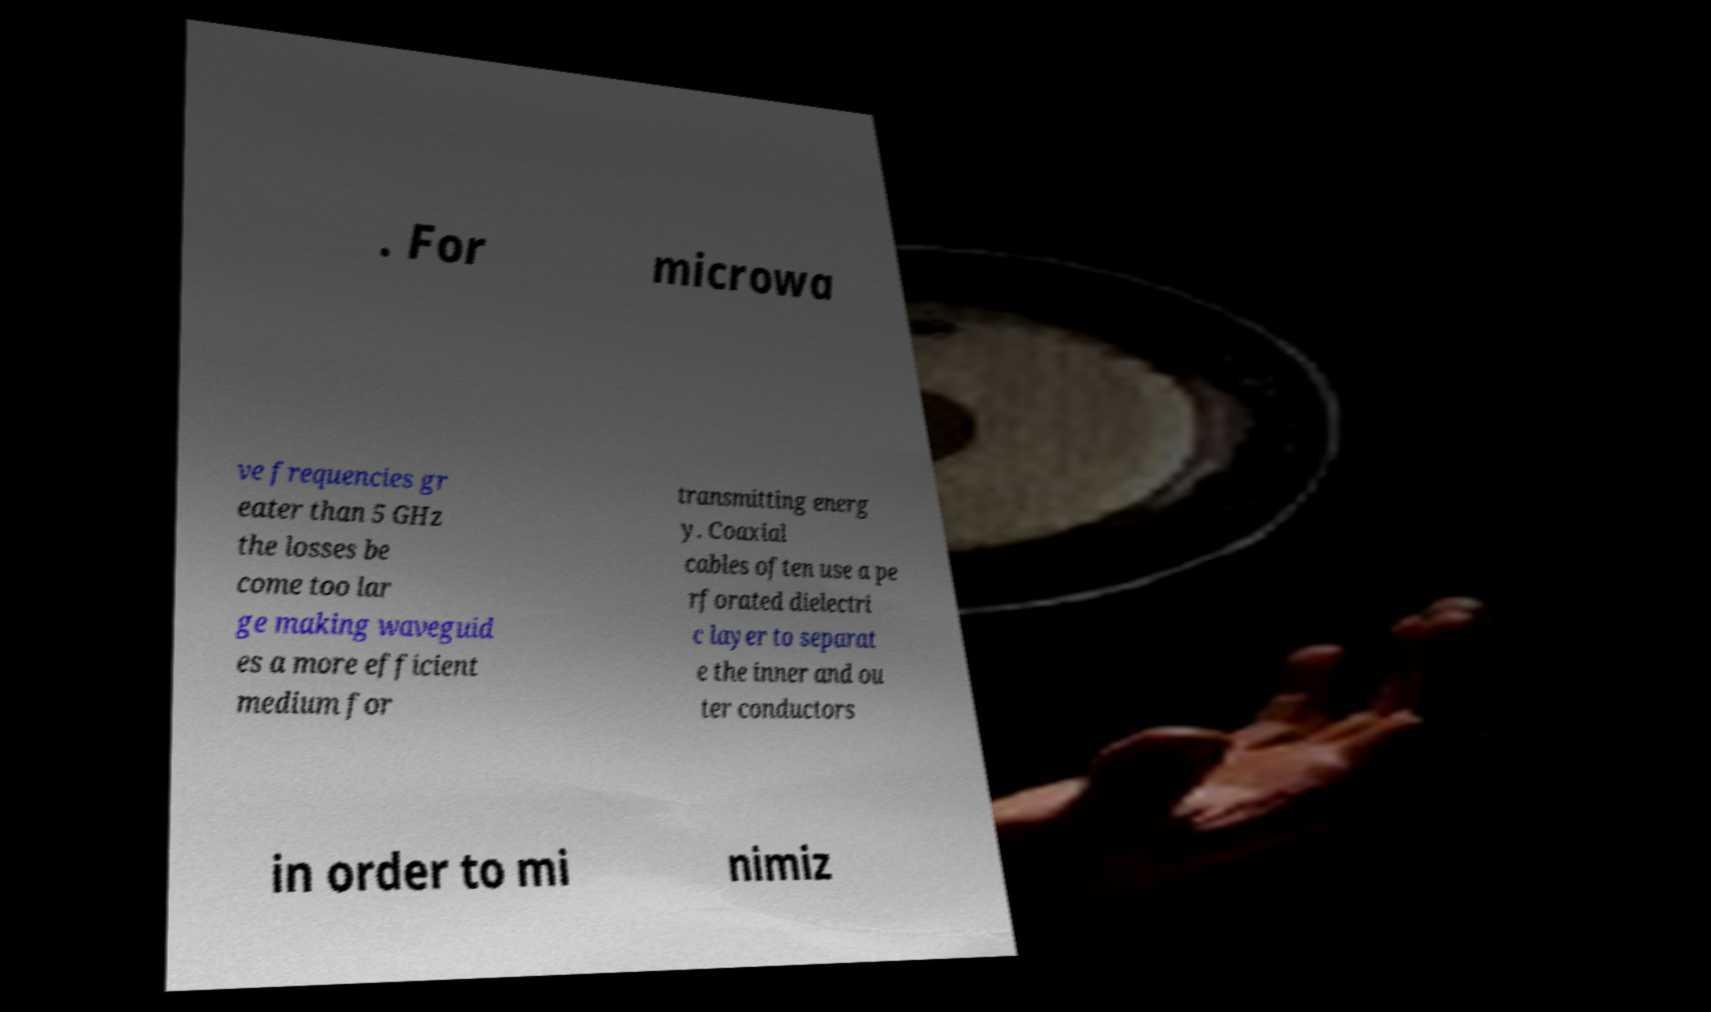There's text embedded in this image that I need extracted. Can you transcribe it verbatim? . For microwa ve frequencies gr eater than 5 GHz the losses be come too lar ge making waveguid es a more efficient medium for transmitting energ y. Coaxial cables often use a pe rforated dielectri c layer to separat e the inner and ou ter conductors in order to mi nimiz 